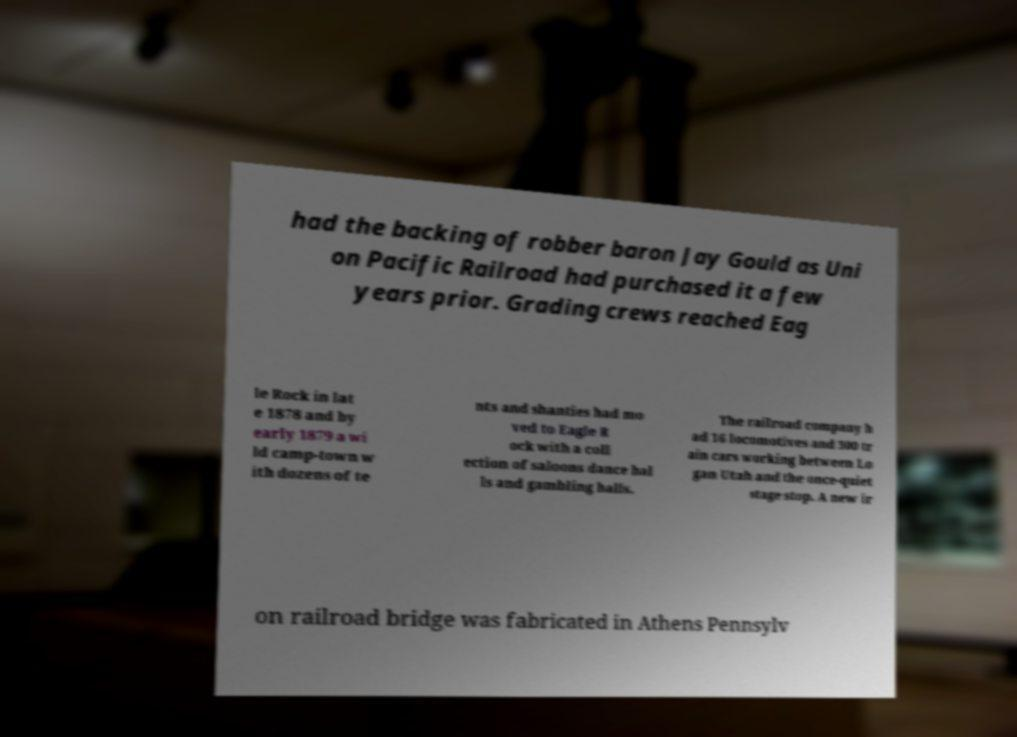Please read and relay the text visible in this image. What does it say? had the backing of robber baron Jay Gould as Uni on Pacific Railroad had purchased it a few years prior. Grading crews reached Eag le Rock in lat e 1878 and by early 1879 a wi ld camp-town w ith dozens of te nts and shanties had mo ved to Eagle R ock with a coll ection of saloons dance hal ls and gambling halls. The railroad company h ad 16 locomotives and 300 tr ain cars working between Lo gan Utah and the once-quiet stage stop. A new ir on railroad bridge was fabricated in Athens Pennsylv 